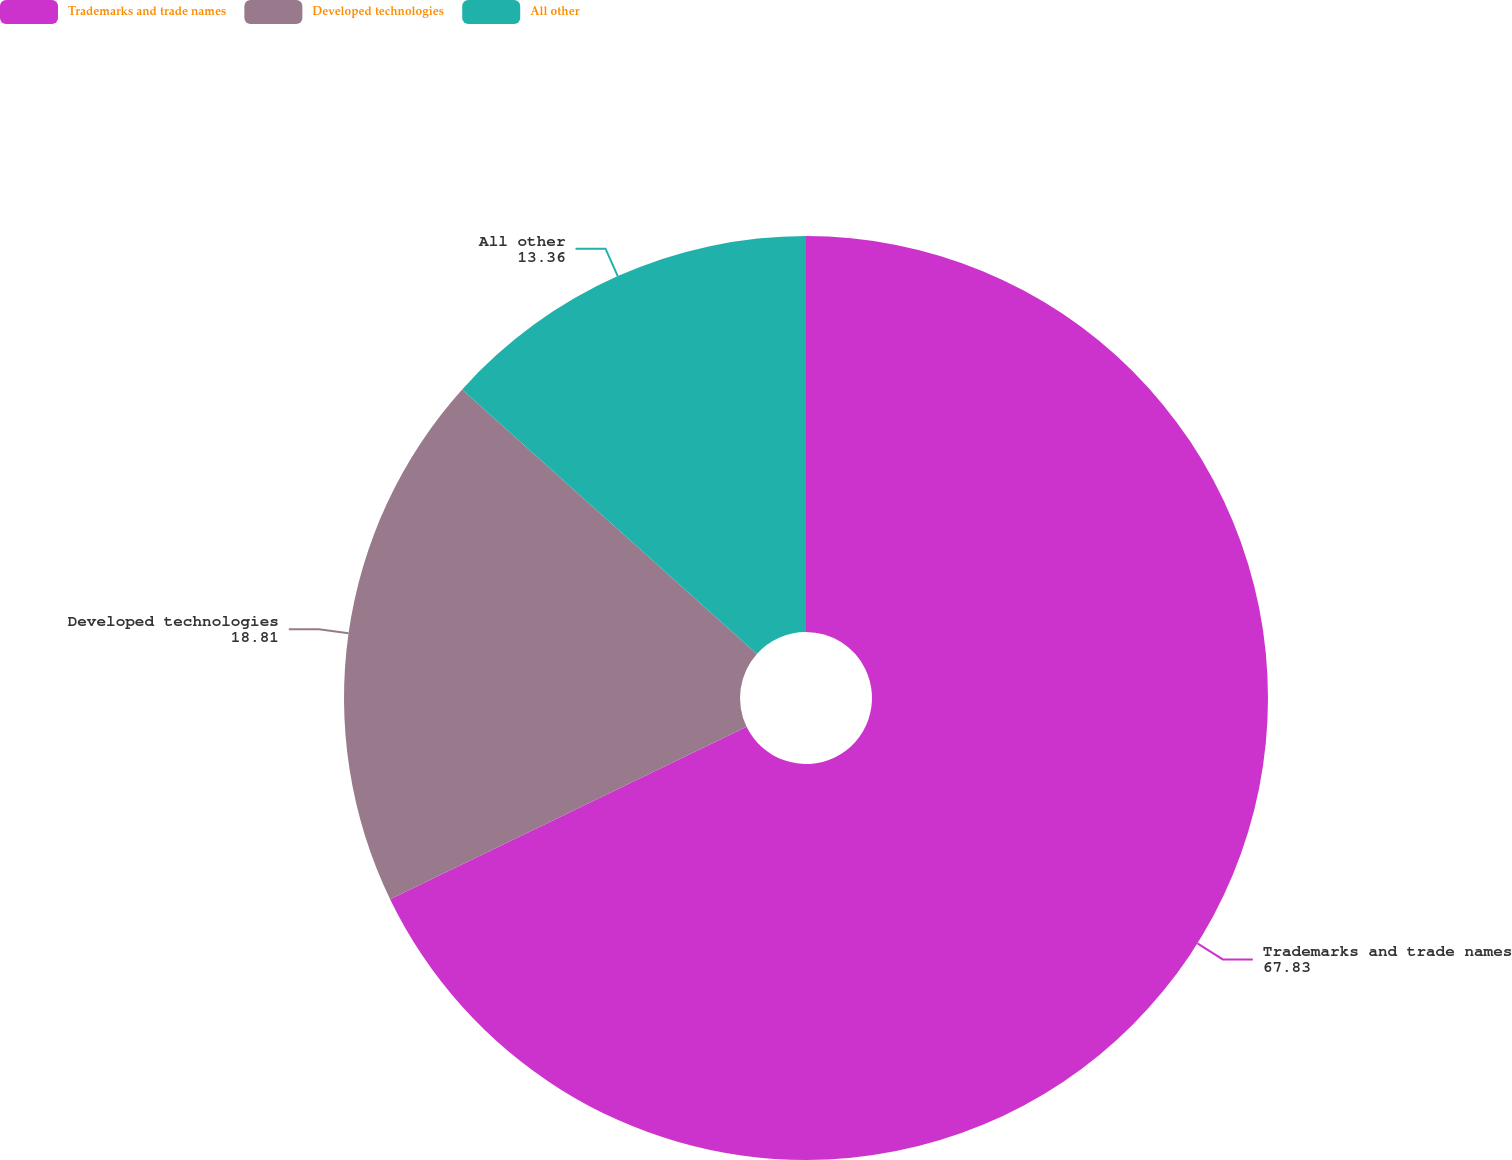Convert chart to OTSL. <chart><loc_0><loc_0><loc_500><loc_500><pie_chart><fcel>Trademarks and trade names<fcel>Developed technologies<fcel>All other<nl><fcel>67.83%<fcel>18.81%<fcel>13.36%<nl></chart> 